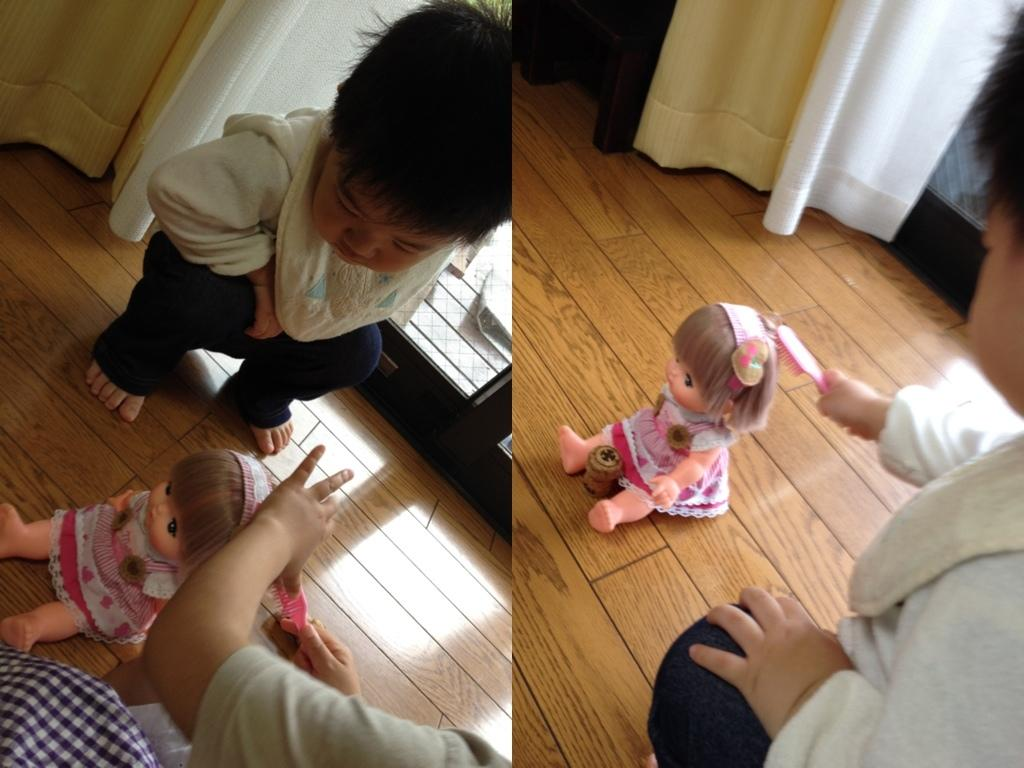What type of artwork is the image? The image is a collage. What can be seen in the collage involving a child? There is a child holding a doll and another child sitting on the floor in the collage. What type of window treatment is present in the collage? There is a curtain in the collage. What architectural feature is visible in the collage? There is a window in the collage. What type of meat is being cooked on the stove in the image? There is no stove or meat present in the image; it is a collage featuring children and a window with a curtain. 